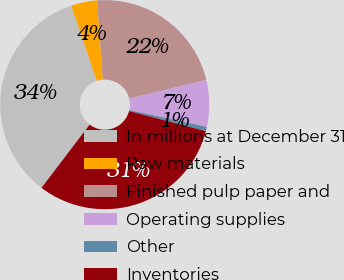Convert chart. <chart><loc_0><loc_0><loc_500><loc_500><pie_chart><fcel>In millions at December 31<fcel>Raw materials<fcel>Finished pulp paper and<fcel>Operating supplies<fcel>Other<fcel>Inventories<nl><fcel>34.45%<fcel>4.03%<fcel>22.38%<fcel>7.21%<fcel>0.66%<fcel>31.27%<nl></chart> 